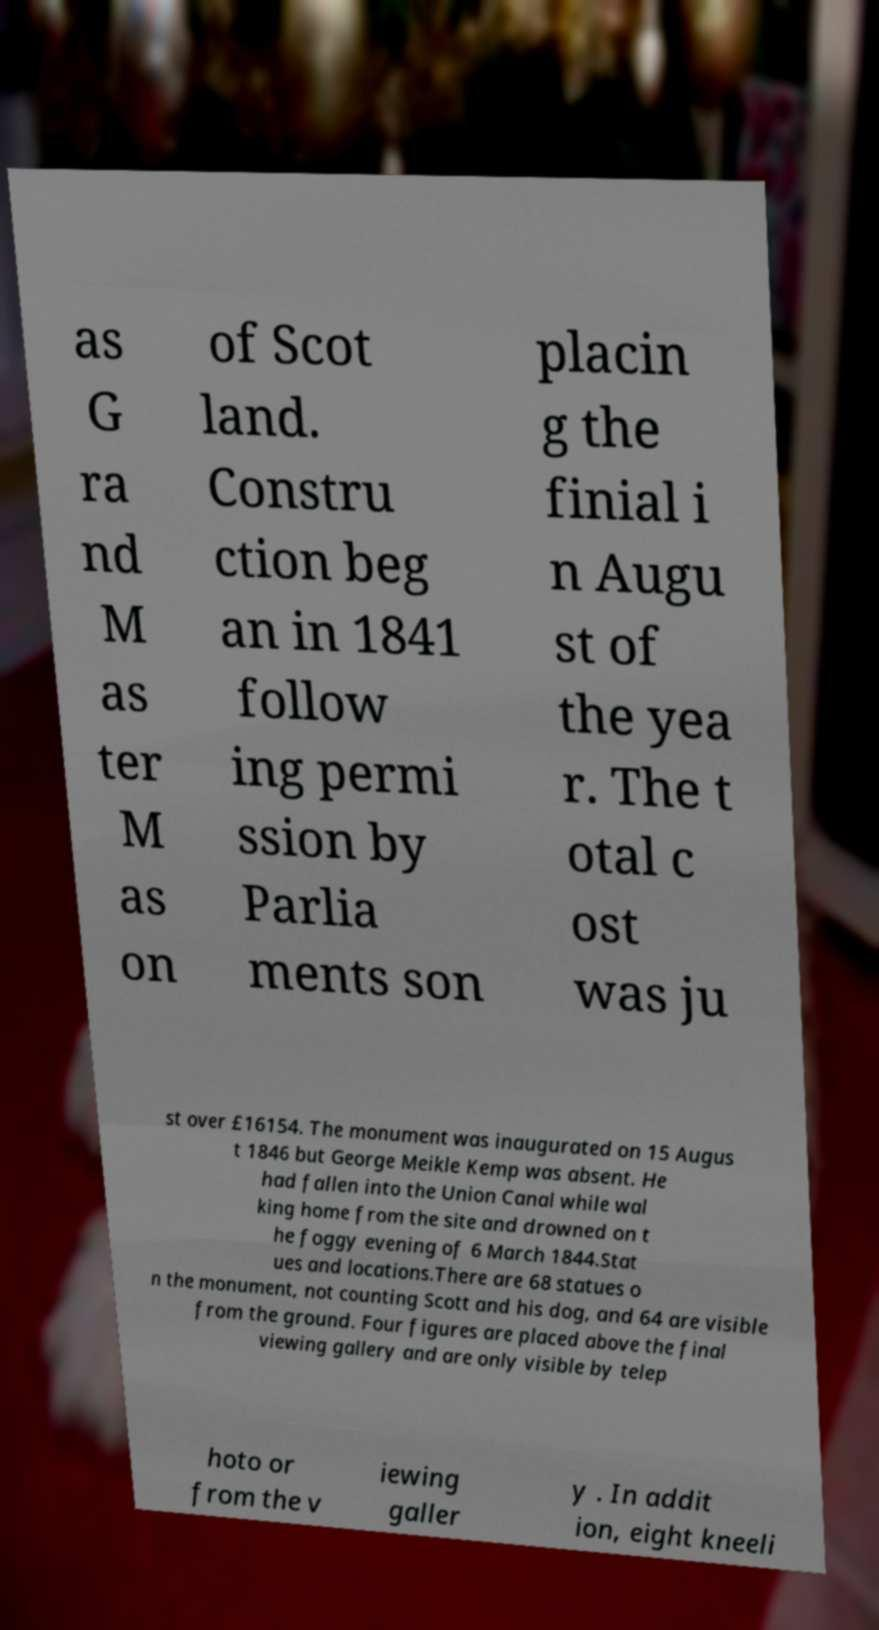Could you assist in decoding the text presented in this image and type it out clearly? as G ra nd M as ter M as on of Scot land. Constru ction beg an in 1841 follow ing permi ssion by Parlia ments son placin g the finial i n Augu st of the yea r. The t otal c ost was ju st over £16154. The monument was inaugurated on 15 Augus t 1846 but George Meikle Kemp was absent. He had fallen into the Union Canal while wal king home from the site and drowned on t he foggy evening of 6 March 1844.Stat ues and locations.There are 68 statues o n the monument, not counting Scott and his dog, and 64 are visible from the ground. Four figures are placed above the final viewing gallery and are only visible by telep hoto or from the v iewing galler y . In addit ion, eight kneeli 